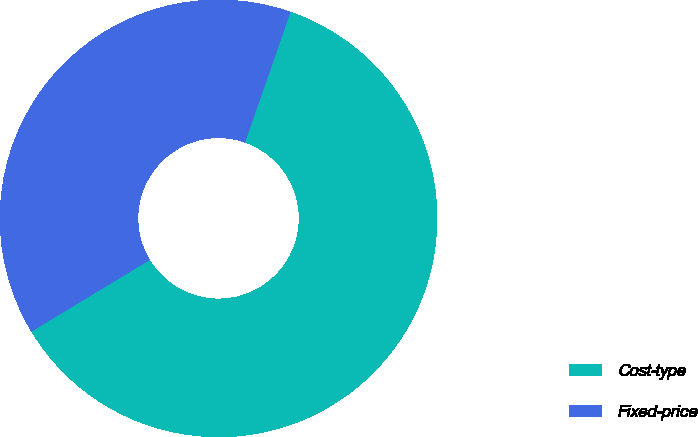Convert chart. <chart><loc_0><loc_0><loc_500><loc_500><pie_chart><fcel>Cost-type<fcel>Fixed-price<nl><fcel>61.0%<fcel>39.0%<nl></chart> 